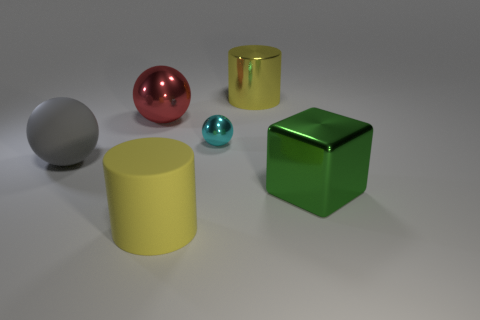Is there anything else that is the same size as the cyan metal object?
Provide a succinct answer. No. Is there any other thing that is the same color as the large shiny cube?
Provide a short and direct response. No. Are there more large green objects that are in front of the large red metallic object than tiny cubes?
Your answer should be compact. Yes. There is a metal object to the left of the cyan object; does it have the same shape as the tiny object?
Your answer should be compact. Yes. What material is the big yellow thing that is left of the small object?
Make the answer very short. Rubber. How many tiny metal objects have the same shape as the big yellow rubber object?
Your answer should be very brief. 0. There is a yellow object that is behind the big shiny thing in front of the large red shiny thing; what is it made of?
Your response must be concise. Metal. The big metallic thing that is the same color as the big matte cylinder is what shape?
Ensure brevity in your answer.  Cylinder. Are there any small cyan objects made of the same material as the large red ball?
Provide a succinct answer. Yes. What is the shape of the big green thing?
Your response must be concise. Cube. 